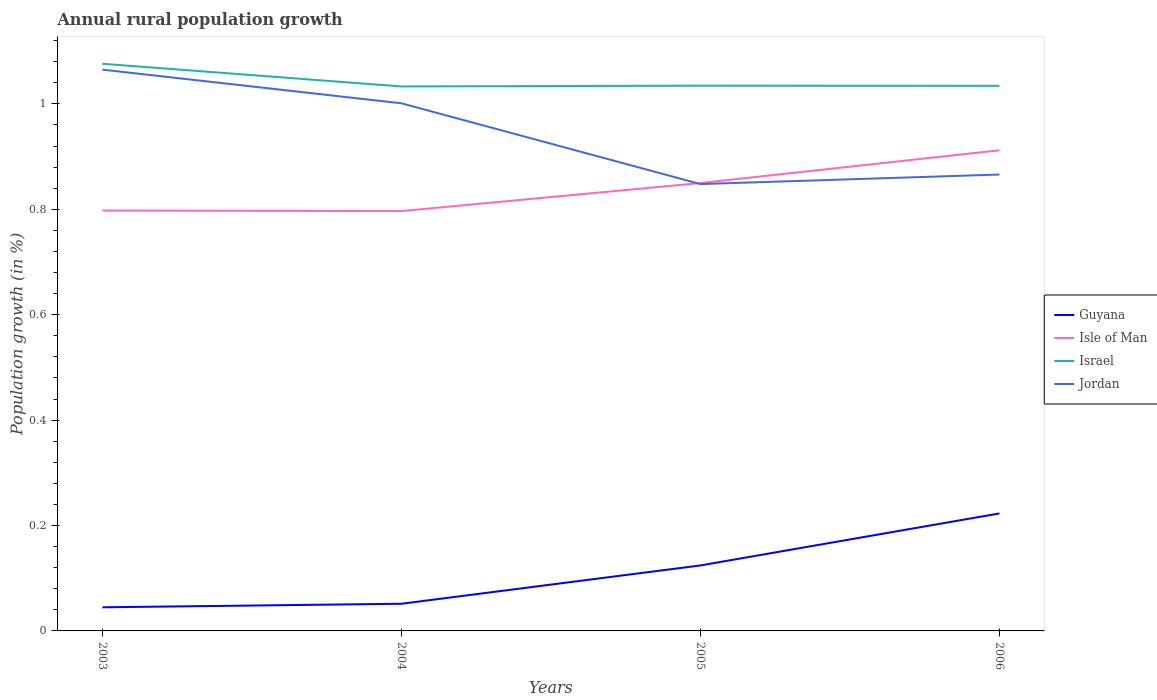Is the number of lines equal to the number of legend labels?
Ensure brevity in your answer.  Yes. Across all years, what is the maximum percentage of rural population growth in Jordan?
Give a very brief answer. 0.85. In which year was the percentage of rural population growth in Jordan maximum?
Keep it short and to the point. 2005. What is the total percentage of rural population growth in Jordan in the graph?
Give a very brief answer. 0.2. What is the difference between the highest and the second highest percentage of rural population growth in Jordan?
Your answer should be very brief. 0.22. What is the difference between the highest and the lowest percentage of rural population growth in Isle of Man?
Your answer should be very brief. 2. How many lines are there?
Offer a very short reply. 4. How many years are there in the graph?
Make the answer very short. 4. What is the difference between two consecutive major ticks on the Y-axis?
Your response must be concise. 0.2. Are the values on the major ticks of Y-axis written in scientific E-notation?
Provide a succinct answer. No. Does the graph contain any zero values?
Your response must be concise. No. Does the graph contain grids?
Provide a succinct answer. No. How are the legend labels stacked?
Your answer should be very brief. Vertical. What is the title of the graph?
Offer a terse response. Annual rural population growth. What is the label or title of the X-axis?
Ensure brevity in your answer.  Years. What is the label or title of the Y-axis?
Make the answer very short. Population growth (in %). What is the Population growth (in %) of Guyana in 2003?
Make the answer very short. 0.04. What is the Population growth (in %) of Isle of Man in 2003?
Offer a terse response. 0.8. What is the Population growth (in %) in Israel in 2003?
Offer a terse response. 1.08. What is the Population growth (in %) in Jordan in 2003?
Provide a short and direct response. 1.07. What is the Population growth (in %) in Guyana in 2004?
Your answer should be very brief. 0.05. What is the Population growth (in %) of Isle of Man in 2004?
Offer a terse response. 0.8. What is the Population growth (in %) in Israel in 2004?
Ensure brevity in your answer.  1.03. What is the Population growth (in %) of Jordan in 2004?
Ensure brevity in your answer.  1. What is the Population growth (in %) of Guyana in 2005?
Offer a terse response. 0.12. What is the Population growth (in %) of Isle of Man in 2005?
Ensure brevity in your answer.  0.85. What is the Population growth (in %) of Israel in 2005?
Keep it short and to the point. 1.03. What is the Population growth (in %) in Jordan in 2005?
Make the answer very short. 0.85. What is the Population growth (in %) in Guyana in 2006?
Give a very brief answer. 0.22. What is the Population growth (in %) of Isle of Man in 2006?
Offer a terse response. 0.91. What is the Population growth (in %) of Israel in 2006?
Keep it short and to the point. 1.03. What is the Population growth (in %) in Jordan in 2006?
Your answer should be compact. 0.87. Across all years, what is the maximum Population growth (in %) in Guyana?
Provide a succinct answer. 0.22. Across all years, what is the maximum Population growth (in %) in Isle of Man?
Provide a succinct answer. 0.91. Across all years, what is the maximum Population growth (in %) in Israel?
Provide a short and direct response. 1.08. Across all years, what is the maximum Population growth (in %) in Jordan?
Provide a short and direct response. 1.07. Across all years, what is the minimum Population growth (in %) of Guyana?
Your answer should be compact. 0.04. Across all years, what is the minimum Population growth (in %) in Isle of Man?
Your answer should be very brief. 0.8. Across all years, what is the minimum Population growth (in %) in Israel?
Keep it short and to the point. 1.03. Across all years, what is the minimum Population growth (in %) of Jordan?
Provide a succinct answer. 0.85. What is the total Population growth (in %) of Guyana in the graph?
Make the answer very short. 0.44. What is the total Population growth (in %) in Isle of Man in the graph?
Ensure brevity in your answer.  3.36. What is the total Population growth (in %) in Israel in the graph?
Give a very brief answer. 4.18. What is the total Population growth (in %) in Jordan in the graph?
Make the answer very short. 3.78. What is the difference between the Population growth (in %) of Guyana in 2003 and that in 2004?
Provide a short and direct response. -0.01. What is the difference between the Population growth (in %) in Isle of Man in 2003 and that in 2004?
Offer a very short reply. 0. What is the difference between the Population growth (in %) of Israel in 2003 and that in 2004?
Ensure brevity in your answer.  0.04. What is the difference between the Population growth (in %) of Jordan in 2003 and that in 2004?
Keep it short and to the point. 0.06. What is the difference between the Population growth (in %) in Guyana in 2003 and that in 2005?
Make the answer very short. -0.08. What is the difference between the Population growth (in %) in Isle of Man in 2003 and that in 2005?
Ensure brevity in your answer.  -0.05. What is the difference between the Population growth (in %) in Israel in 2003 and that in 2005?
Keep it short and to the point. 0.04. What is the difference between the Population growth (in %) of Jordan in 2003 and that in 2005?
Give a very brief answer. 0.22. What is the difference between the Population growth (in %) of Guyana in 2003 and that in 2006?
Offer a terse response. -0.18. What is the difference between the Population growth (in %) of Isle of Man in 2003 and that in 2006?
Offer a terse response. -0.11. What is the difference between the Population growth (in %) in Israel in 2003 and that in 2006?
Your answer should be compact. 0.04. What is the difference between the Population growth (in %) of Jordan in 2003 and that in 2006?
Your answer should be very brief. 0.2. What is the difference between the Population growth (in %) in Guyana in 2004 and that in 2005?
Offer a very short reply. -0.07. What is the difference between the Population growth (in %) of Isle of Man in 2004 and that in 2005?
Your response must be concise. -0.05. What is the difference between the Population growth (in %) of Israel in 2004 and that in 2005?
Provide a succinct answer. -0. What is the difference between the Population growth (in %) of Jordan in 2004 and that in 2005?
Your answer should be very brief. 0.15. What is the difference between the Population growth (in %) in Guyana in 2004 and that in 2006?
Give a very brief answer. -0.17. What is the difference between the Population growth (in %) of Isle of Man in 2004 and that in 2006?
Offer a terse response. -0.12. What is the difference between the Population growth (in %) in Israel in 2004 and that in 2006?
Offer a terse response. -0. What is the difference between the Population growth (in %) of Jordan in 2004 and that in 2006?
Keep it short and to the point. 0.14. What is the difference between the Population growth (in %) of Guyana in 2005 and that in 2006?
Your answer should be compact. -0.1. What is the difference between the Population growth (in %) in Isle of Man in 2005 and that in 2006?
Your response must be concise. -0.06. What is the difference between the Population growth (in %) in Jordan in 2005 and that in 2006?
Offer a very short reply. -0.02. What is the difference between the Population growth (in %) of Guyana in 2003 and the Population growth (in %) of Isle of Man in 2004?
Your answer should be very brief. -0.75. What is the difference between the Population growth (in %) of Guyana in 2003 and the Population growth (in %) of Israel in 2004?
Provide a succinct answer. -0.99. What is the difference between the Population growth (in %) in Guyana in 2003 and the Population growth (in %) in Jordan in 2004?
Give a very brief answer. -0.96. What is the difference between the Population growth (in %) in Isle of Man in 2003 and the Population growth (in %) in Israel in 2004?
Offer a very short reply. -0.24. What is the difference between the Population growth (in %) of Isle of Man in 2003 and the Population growth (in %) of Jordan in 2004?
Offer a terse response. -0.2. What is the difference between the Population growth (in %) in Israel in 2003 and the Population growth (in %) in Jordan in 2004?
Provide a short and direct response. 0.07. What is the difference between the Population growth (in %) in Guyana in 2003 and the Population growth (in %) in Isle of Man in 2005?
Give a very brief answer. -0.81. What is the difference between the Population growth (in %) in Guyana in 2003 and the Population growth (in %) in Israel in 2005?
Give a very brief answer. -0.99. What is the difference between the Population growth (in %) of Guyana in 2003 and the Population growth (in %) of Jordan in 2005?
Keep it short and to the point. -0.8. What is the difference between the Population growth (in %) of Isle of Man in 2003 and the Population growth (in %) of Israel in 2005?
Offer a very short reply. -0.24. What is the difference between the Population growth (in %) of Isle of Man in 2003 and the Population growth (in %) of Jordan in 2005?
Your answer should be very brief. -0.05. What is the difference between the Population growth (in %) in Israel in 2003 and the Population growth (in %) in Jordan in 2005?
Offer a terse response. 0.23. What is the difference between the Population growth (in %) of Guyana in 2003 and the Population growth (in %) of Isle of Man in 2006?
Your response must be concise. -0.87. What is the difference between the Population growth (in %) of Guyana in 2003 and the Population growth (in %) of Israel in 2006?
Provide a short and direct response. -0.99. What is the difference between the Population growth (in %) in Guyana in 2003 and the Population growth (in %) in Jordan in 2006?
Ensure brevity in your answer.  -0.82. What is the difference between the Population growth (in %) of Isle of Man in 2003 and the Population growth (in %) of Israel in 2006?
Offer a very short reply. -0.24. What is the difference between the Population growth (in %) of Isle of Man in 2003 and the Population growth (in %) of Jordan in 2006?
Keep it short and to the point. -0.07. What is the difference between the Population growth (in %) of Israel in 2003 and the Population growth (in %) of Jordan in 2006?
Your answer should be compact. 0.21. What is the difference between the Population growth (in %) in Guyana in 2004 and the Population growth (in %) in Isle of Man in 2005?
Offer a very short reply. -0.8. What is the difference between the Population growth (in %) of Guyana in 2004 and the Population growth (in %) of Israel in 2005?
Your answer should be very brief. -0.98. What is the difference between the Population growth (in %) in Guyana in 2004 and the Population growth (in %) in Jordan in 2005?
Provide a short and direct response. -0.8. What is the difference between the Population growth (in %) in Isle of Man in 2004 and the Population growth (in %) in Israel in 2005?
Provide a succinct answer. -0.24. What is the difference between the Population growth (in %) of Isle of Man in 2004 and the Population growth (in %) of Jordan in 2005?
Ensure brevity in your answer.  -0.05. What is the difference between the Population growth (in %) of Israel in 2004 and the Population growth (in %) of Jordan in 2005?
Your response must be concise. 0.19. What is the difference between the Population growth (in %) in Guyana in 2004 and the Population growth (in %) in Isle of Man in 2006?
Your response must be concise. -0.86. What is the difference between the Population growth (in %) of Guyana in 2004 and the Population growth (in %) of Israel in 2006?
Make the answer very short. -0.98. What is the difference between the Population growth (in %) in Guyana in 2004 and the Population growth (in %) in Jordan in 2006?
Offer a terse response. -0.81. What is the difference between the Population growth (in %) of Isle of Man in 2004 and the Population growth (in %) of Israel in 2006?
Ensure brevity in your answer.  -0.24. What is the difference between the Population growth (in %) in Isle of Man in 2004 and the Population growth (in %) in Jordan in 2006?
Offer a terse response. -0.07. What is the difference between the Population growth (in %) of Israel in 2004 and the Population growth (in %) of Jordan in 2006?
Provide a short and direct response. 0.17. What is the difference between the Population growth (in %) of Guyana in 2005 and the Population growth (in %) of Isle of Man in 2006?
Ensure brevity in your answer.  -0.79. What is the difference between the Population growth (in %) of Guyana in 2005 and the Population growth (in %) of Israel in 2006?
Offer a very short reply. -0.91. What is the difference between the Population growth (in %) in Guyana in 2005 and the Population growth (in %) in Jordan in 2006?
Keep it short and to the point. -0.74. What is the difference between the Population growth (in %) of Isle of Man in 2005 and the Population growth (in %) of Israel in 2006?
Offer a very short reply. -0.18. What is the difference between the Population growth (in %) in Isle of Man in 2005 and the Population growth (in %) in Jordan in 2006?
Offer a very short reply. -0.02. What is the difference between the Population growth (in %) in Israel in 2005 and the Population growth (in %) in Jordan in 2006?
Provide a succinct answer. 0.17. What is the average Population growth (in %) in Guyana per year?
Your response must be concise. 0.11. What is the average Population growth (in %) of Isle of Man per year?
Your answer should be compact. 0.84. What is the average Population growth (in %) in Israel per year?
Your answer should be compact. 1.04. What is the average Population growth (in %) in Jordan per year?
Your answer should be compact. 0.94. In the year 2003, what is the difference between the Population growth (in %) of Guyana and Population growth (in %) of Isle of Man?
Provide a succinct answer. -0.75. In the year 2003, what is the difference between the Population growth (in %) in Guyana and Population growth (in %) in Israel?
Make the answer very short. -1.03. In the year 2003, what is the difference between the Population growth (in %) of Guyana and Population growth (in %) of Jordan?
Provide a short and direct response. -1.02. In the year 2003, what is the difference between the Population growth (in %) of Isle of Man and Population growth (in %) of Israel?
Give a very brief answer. -0.28. In the year 2003, what is the difference between the Population growth (in %) of Isle of Man and Population growth (in %) of Jordan?
Your answer should be compact. -0.27. In the year 2003, what is the difference between the Population growth (in %) of Israel and Population growth (in %) of Jordan?
Offer a very short reply. 0.01. In the year 2004, what is the difference between the Population growth (in %) of Guyana and Population growth (in %) of Isle of Man?
Give a very brief answer. -0.74. In the year 2004, what is the difference between the Population growth (in %) of Guyana and Population growth (in %) of Israel?
Give a very brief answer. -0.98. In the year 2004, what is the difference between the Population growth (in %) of Guyana and Population growth (in %) of Jordan?
Offer a terse response. -0.95. In the year 2004, what is the difference between the Population growth (in %) of Isle of Man and Population growth (in %) of Israel?
Offer a terse response. -0.24. In the year 2004, what is the difference between the Population growth (in %) of Isle of Man and Population growth (in %) of Jordan?
Give a very brief answer. -0.2. In the year 2004, what is the difference between the Population growth (in %) of Israel and Population growth (in %) of Jordan?
Provide a succinct answer. 0.03. In the year 2005, what is the difference between the Population growth (in %) of Guyana and Population growth (in %) of Isle of Man?
Keep it short and to the point. -0.73. In the year 2005, what is the difference between the Population growth (in %) of Guyana and Population growth (in %) of Israel?
Make the answer very short. -0.91. In the year 2005, what is the difference between the Population growth (in %) in Guyana and Population growth (in %) in Jordan?
Ensure brevity in your answer.  -0.72. In the year 2005, what is the difference between the Population growth (in %) of Isle of Man and Population growth (in %) of Israel?
Your answer should be compact. -0.18. In the year 2005, what is the difference between the Population growth (in %) in Isle of Man and Population growth (in %) in Jordan?
Your answer should be very brief. 0. In the year 2005, what is the difference between the Population growth (in %) of Israel and Population growth (in %) of Jordan?
Give a very brief answer. 0.19. In the year 2006, what is the difference between the Population growth (in %) in Guyana and Population growth (in %) in Isle of Man?
Your answer should be compact. -0.69. In the year 2006, what is the difference between the Population growth (in %) of Guyana and Population growth (in %) of Israel?
Ensure brevity in your answer.  -0.81. In the year 2006, what is the difference between the Population growth (in %) in Guyana and Population growth (in %) in Jordan?
Your answer should be compact. -0.64. In the year 2006, what is the difference between the Population growth (in %) of Isle of Man and Population growth (in %) of Israel?
Your answer should be compact. -0.12. In the year 2006, what is the difference between the Population growth (in %) of Isle of Man and Population growth (in %) of Jordan?
Offer a terse response. 0.05. In the year 2006, what is the difference between the Population growth (in %) in Israel and Population growth (in %) in Jordan?
Offer a very short reply. 0.17. What is the ratio of the Population growth (in %) of Guyana in 2003 to that in 2004?
Make the answer very short. 0.87. What is the ratio of the Population growth (in %) of Isle of Man in 2003 to that in 2004?
Provide a succinct answer. 1. What is the ratio of the Population growth (in %) in Israel in 2003 to that in 2004?
Your response must be concise. 1.04. What is the ratio of the Population growth (in %) in Jordan in 2003 to that in 2004?
Ensure brevity in your answer.  1.06. What is the ratio of the Population growth (in %) in Guyana in 2003 to that in 2005?
Offer a terse response. 0.36. What is the ratio of the Population growth (in %) in Isle of Man in 2003 to that in 2005?
Your answer should be compact. 0.94. What is the ratio of the Population growth (in %) of Israel in 2003 to that in 2005?
Your answer should be compact. 1.04. What is the ratio of the Population growth (in %) in Jordan in 2003 to that in 2005?
Provide a succinct answer. 1.26. What is the ratio of the Population growth (in %) of Guyana in 2003 to that in 2006?
Provide a short and direct response. 0.2. What is the ratio of the Population growth (in %) of Isle of Man in 2003 to that in 2006?
Offer a very short reply. 0.87. What is the ratio of the Population growth (in %) of Israel in 2003 to that in 2006?
Ensure brevity in your answer.  1.04. What is the ratio of the Population growth (in %) in Jordan in 2003 to that in 2006?
Ensure brevity in your answer.  1.23. What is the ratio of the Population growth (in %) of Guyana in 2004 to that in 2005?
Your response must be concise. 0.41. What is the ratio of the Population growth (in %) of Isle of Man in 2004 to that in 2005?
Offer a very short reply. 0.94. What is the ratio of the Population growth (in %) of Israel in 2004 to that in 2005?
Provide a succinct answer. 1. What is the ratio of the Population growth (in %) in Jordan in 2004 to that in 2005?
Your answer should be compact. 1.18. What is the ratio of the Population growth (in %) of Guyana in 2004 to that in 2006?
Provide a short and direct response. 0.23. What is the ratio of the Population growth (in %) in Isle of Man in 2004 to that in 2006?
Provide a short and direct response. 0.87. What is the ratio of the Population growth (in %) in Jordan in 2004 to that in 2006?
Make the answer very short. 1.16. What is the ratio of the Population growth (in %) of Guyana in 2005 to that in 2006?
Make the answer very short. 0.56. What is the ratio of the Population growth (in %) of Isle of Man in 2005 to that in 2006?
Give a very brief answer. 0.93. What is the ratio of the Population growth (in %) in Israel in 2005 to that in 2006?
Your answer should be compact. 1. What is the ratio of the Population growth (in %) in Jordan in 2005 to that in 2006?
Offer a very short reply. 0.98. What is the difference between the highest and the second highest Population growth (in %) in Guyana?
Give a very brief answer. 0.1. What is the difference between the highest and the second highest Population growth (in %) in Isle of Man?
Make the answer very short. 0.06. What is the difference between the highest and the second highest Population growth (in %) in Israel?
Make the answer very short. 0.04. What is the difference between the highest and the second highest Population growth (in %) in Jordan?
Make the answer very short. 0.06. What is the difference between the highest and the lowest Population growth (in %) in Guyana?
Your response must be concise. 0.18. What is the difference between the highest and the lowest Population growth (in %) in Isle of Man?
Give a very brief answer. 0.12. What is the difference between the highest and the lowest Population growth (in %) of Israel?
Your answer should be compact. 0.04. What is the difference between the highest and the lowest Population growth (in %) in Jordan?
Ensure brevity in your answer.  0.22. 